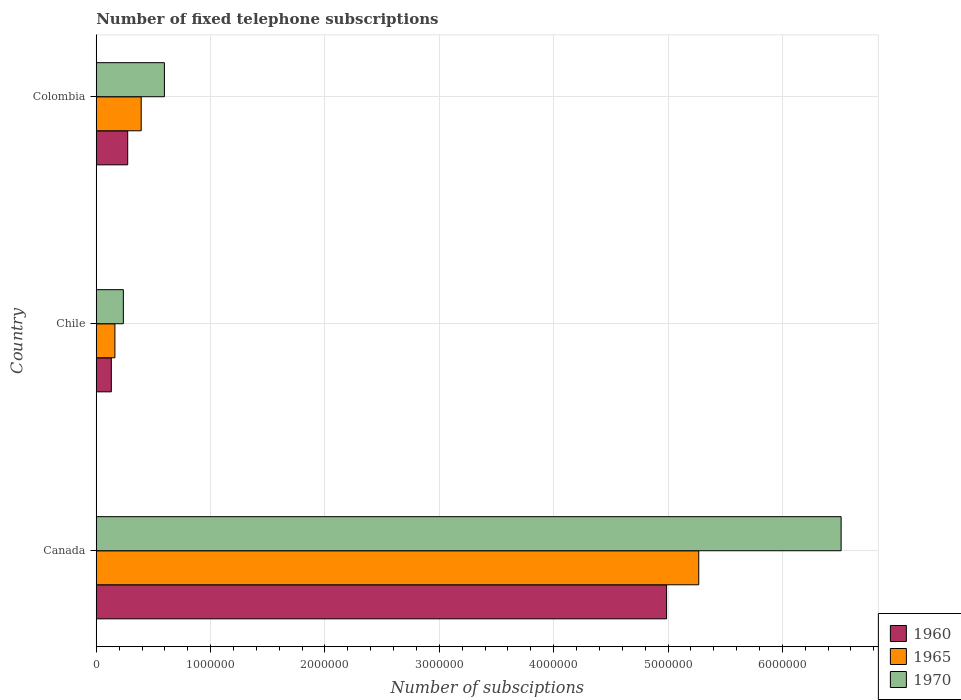How many different coloured bars are there?
Make the answer very short. 3. How many bars are there on the 2nd tick from the top?
Keep it short and to the point. 3. How many bars are there on the 2nd tick from the bottom?
Offer a terse response. 3. In how many cases, is the number of bars for a given country not equal to the number of legend labels?
Keep it short and to the point. 0. What is the number of fixed telephone subscriptions in 1965 in Chile?
Your response must be concise. 1.63e+05. Across all countries, what is the maximum number of fixed telephone subscriptions in 1965?
Your answer should be compact. 5.27e+06. Across all countries, what is the minimum number of fixed telephone subscriptions in 1970?
Make the answer very short. 2.37e+05. In which country was the number of fixed telephone subscriptions in 1960 minimum?
Provide a short and direct response. Chile. What is the total number of fixed telephone subscriptions in 1970 in the graph?
Your answer should be very brief. 7.35e+06. What is the difference between the number of fixed telephone subscriptions in 1965 in Canada and that in Chile?
Make the answer very short. 5.11e+06. What is the difference between the number of fixed telephone subscriptions in 1965 in Canada and the number of fixed telephone subscriptions in 1960 in Colombia?
Give a very brief answer. 4.99e+06. What is the average number of fixed telephone subscriptions in 1965 per country?
Your answer should be very brief. 1.94e+06. What is the difference between the number of fixed telephone subscriptions in 1960 and number of fixed telephone subscriptions in 1965 in Chile?
Ensure brevity in your answer.  -3.12e+04. In how many countries, is the number of fixed telephone subscriptions in 1970 greater than 3200000 ?
Offer a terse response. 1. What is the ratio of the number of fixed telephone subscriptions in 1970 in Chile to that in Colombia?
Offer a terse response. 0.4. What is the difference between the highest and the second highest number of fixed telephone subscriptions in 1965?
Ensure brevity in your answer.  4.88e+06. What is the difference between the highest and the lowest number of fixed telephone subscriptions in 1960?
Provide a short and direct response. 4.86e+06. In how many countries, is the number of fixed telephone subscriptions in 1970 greater than the average number of fixed telephone subscriptions in 1970 taken over all countries?
Provide a short and direct response. 1. What does the 2nd bar from the top in Canada represents?
Ensure brevity in your answer.  1965. What does the 3rd bar from the bottom in Chile represents?
Make the answer very short. 1970. Does the graph contain grids?
Offer a very short reply. Yes. How many legend labels are there?
Offer a terse response. 3. What is the title of the graph?
Your answer should be very brief. Number of fixed telephone subscriptions. Does "2007" appear as one of the legend labels in the graph?
Make the answer very short. No. What is the label or title of the X-axis?
Offer a terse response. Number of subsciptions. What is the label or title of the Y-axis?
Your response must be concise. Country. What is the Number of subsciptions of 1960 in Canada?
Offer a terse response. 4.99e+06. What is the Number of subsciptions in 1965 in Canada?
Your answer should be compact. 5.27e+06. What is the Number of subsciptions of 1970 in Canada?
Ensure brevity in your answer.  6.51e+06. What is the Number of subsciptions in 1960 in Chile?
Provide a short and direct response. 1.32e+05. What is the Number of subsciptions of 1965 in Chile?
Your answer should be very brief. 1.63e+05. What is the Number of subsciptions of 1970 in Chile?
Provide a succinct answer. 2.37e+05. What is the Number of subsciptions of 1960 in Colombia?
Your answer should be compact. 2.75e+05. What is the Number of subsciptions of 1965 in Colombia?
Offer a terse response. 3.93e+05. What is the Number of subsciptions of 1970 in Colombia?
Your answer should be compact. 5.96e+05. Across all countries, what is the maximum Number of subsciptions of 1960?
Ensure brevity in your answer.  4.99e+06. Across all countries, what is the maximum Number of subsciptions in 1965?
Your answer should be compact. 5.27e+06. Across all countries, what is the maximum Number of subsciptions of 1970?
Offer a terse response. 6.51e+06. Across all countries, what is the minimum Number of subsciptions of 1960?
Make the answer very short. 1.32e+05. Across all countries, what is the minimum Number of subsciptions in 1965?
Your answer should be compact. 1.63e+05. Across all countries, what is the minimum Number of subsciptions in 1970?
Your response must be concise. 2.37e+05. What is the total Number of subsciptions of 1960 in the graph?
Offer a terse response. 5.39e+06. What is the total Number of subsciptions in 1965 in the graph?
Provide a short and direct response. 5.82e+06. What is the total Number of subsciptions of 1970 in the graph?
Give a very brief answer. 7.35e+06. What is the difference between the Number of subsciptions of 1960 in Canada and that in Chile?
Your answer should be compact. 4.86e+06. What is the difference between the Number of subsciptions of 1965 in Canada and that in Chile?
Your answer should be very brief. 5.11e+06. What is the difference between the Number of subsciptions in 1970 in Canada and that in Chile?
Provide a short and direct response. 6.28e+06. What is the difference between the Number of subsciptions of 1960 in Canada and that in Colombia?
Provide a short and direct response. 4.71e+06. What is the difference between the Number of subsciptions of 1965 in Canada and that in Colombia?
Your response must be concise. 4.88e+06. What is the difference between the Number of subsciptions of 1970 in Canada and that in Colombia?
Give a very brief answer. 5.92e+06. What is the difference between the Number of subsciptions in 1960 in Chile and that in Colombia?
Offer a very short reply. -1.43e+05. What is the difference between the Number of subsciptions of 1970 in Chile and that in Colombia?
Ensure brevity in your answer.  -3.59e+05. What is the difference between the Number of subsciptions of 1960 in Canada and the Number of subsciptions of 1965 in Chile?
Your answer should be compact. 4.82e+06. What is the difference between the Number of subsciptions of 1960 in Canada and the Number of subsciptions of 1970 in Chile?
Ensure brevity in your answer.  4.75e+06. What is the difference between the Number of subsciptions in 1965 in Canada and the Number of subsciptions in 1970 in Chile?
Give a very brief answer. 5.03e+06. What is the difference between the Number of subsciptions in 1960 in Canada and the Number of subsciptions in 1965 in Colombia?
Your response must be concise. 4.59e+06. What is the difference between the Number of subsciptions in 1960 in Canada and the Number of subsciptions in 1970 in Colombia?
Ensure brevity in your answer.  4.39e+06. What is the difference between the Number of subsciptions of 1965 in Canada and the Number of subsciptions of 1970 in Colombia?
Your answer should be very brief. 4.67e+06. What is the difference between the Number of subsciptions in 1960 in Chile and the Number of subsciptions in 1965 in Colombia?
Offer a very short reply. -2.61e+05. What is the difference between the Number of subsciptions of 1960 in Chile and the Number of subsciptions of 1970 in Colombia?
Give a very brief answer. -4.64e+05. What is the difference between the Number of subsciptions of 1965 in Chile and the Number of subsciptions of 1970 in Colombia?
Provide a short and direct response. -4.33e+05. What is the average Number of subsciptions of 1960 per country?
Ensure brevity in your answer.  1.80e+06. What is the average Number of subsciptions in 1965 per country?
Offer a terse response. 1.94e+06. What is the average Number of subsciptions in 1970 per country?
Keep it short and to the point. 2.45e+06. What is the difference between the Number of subsciptions of 1960 and Number of subsciptions of 1965 in Canada?
Give a very brief answer. -2.81e+05. What is the difference between the Number of subsciptions of 1960 and Number of subsciptions of 1970 in Canada?
Your answer should be very brief. -1.53e+06. What is the difference between the Number of subsciptions in 1965 and Number of subsciptions in 1970 in Canada?
Your answer should be very brief. -1.24e+06. What is the difference between the Number of subsciptions of 1960 and Number of subsciptions of 1965 in Chile?
Keep it short and to the point. -3.12e+04. What is the difference between the Number of subsciptions of 1960 and Number of subsciptions of 1970 in Chile?
Your response must be concise. -1.05e+05. What is the difference between the Number of subsciptions in 1965 and Number of subsciptions in 1970 in Chile?
Your answer should be compact. -7.40e+04. What is the difference between the Number of subsciptions of 1960 and Number of subsciptions of 1965 in Colombia?
Keep it short and to the point. -1.18e+05. What is the difference between the Number of subsciptions of 1960 and Number of subsciptions of 1970 in Colombia?
Your response must be concise. -3.21e+05. What is the difference between the Number of subsciptions in 1965 and Number of subsciptions in 1970 in Colombia?
Give a very brief answer. -2.03e+05. What is the ratio of the Number of subsciptions of 1960 in Canada to that in Chile?
Offer a terse response. 37.84. What is the ratio of the Number of subsciptions in 1965 in Canada to that in Chile?
Your answer should be compact. 32.33. What is the ratio of the Number of subsciptions of 1970 in Canada to that in Chile?
Your response must be concise. 27.49. What is the ratio of the Number of subsciptions of 1960 in Canada to that in Colombia?
Offer a terse response. 18.14. What is the ratio of the Number of subsciptions of 1965 in Canada to that in Colombia?
Your answer should be compact. 13.41. What is the ratio of the Number of subsciptions of 1970 in Canada to that in Colombia?
Offer a very short reply. 10.93. What is the ratio of the Number of subsciptions in 1960 in Chile to that in Colombia?
Offer a very short reply. 0.48. What is the ratio of the Number of subsciptions in 1965 in Chile to that in Colombia?
Offer a very short reply. 0.41. What is the ratio of the Number of subsciptions of 1970 in Chile to that in Colombia?
Your answer should be compact. 0.4. What is the difference between the highest and the second highest Number of subsciptions of 1960?
Keep it short and to the point. 4.71e+06. What is the difference between the highest and the second highest Number of subsciptions of 1965?
Ensure brevity in your answer.  4.88e+06. What is the difference between the highest and the second highest Number of subsciptions in 1970?
Give a very brief answer. 5.92e+06. What is the difference between the highest and the lowest Number of subsciptions in 1960?
Keep it short and to the point. 4.86e+06. What is the difference between the highest and the lowest Number of subsciptions in 1965?
Your answer should be very brief. 5.11e+06. What is the difference between the highest and the lowest Number of subsciptions in 1970?
Offer a very short reply. 6.28e+06. 